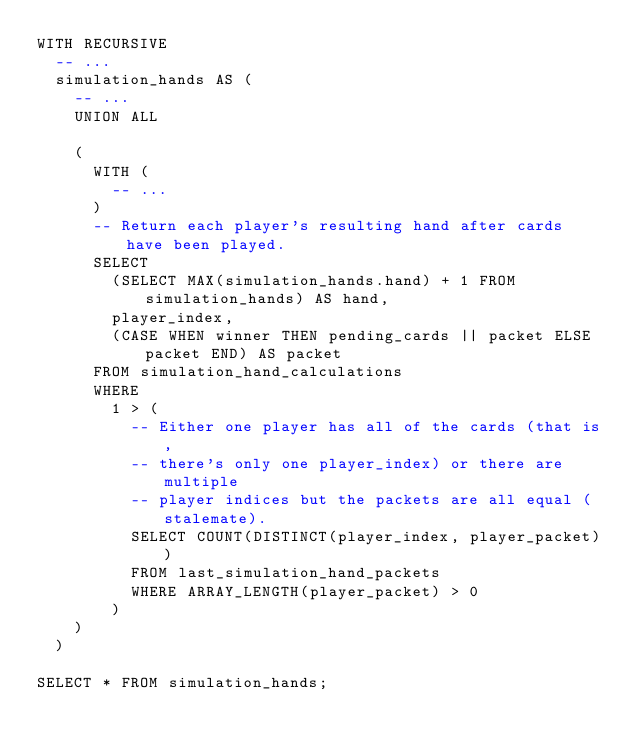Convert code to text. <code><loc_0><loc_0><loc_500><loc_500><_SQL_>WITH RECURSIVE
  -- ...
  simulation_hands AS (
    -- ...
    UNION ALL

    (
      WITH (
        -- ...
      )
      -- Return each player's resulting hand after cards have been played.
      SELECT
        (SELECT MAX(simulation_hands.hand) + 1 FROM simulation_hands) AS hand,
        player_index,
        (CASE WHEN winner THEN pending_cards || packet ELSE packet END) AS packet
      FROM simulation_hand_calculations
      WHERE
        1 > (
          -- Either one player has all of the cards (that is,
          -- there's only one player_index) or there are multiple
          -- player indices but the packets are all equal (stalemate).
          SELECT COUNT(DISTINCT(player_index, player_packet))
          FROM last_simulation_hand_packets
          WHERE ARRAY_LENGTH(player_packet) > 0
        )
    )
  )

SELECT * FROM simulation_hands;
</code> 